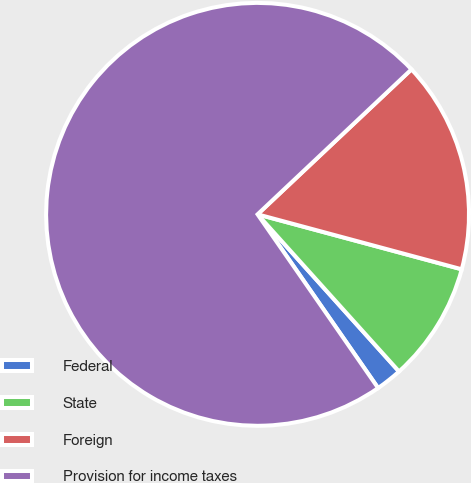Convert chart to OTSL. <chart><loc_0><loc_0><loc_500><loc_500><pie_chart><fcel>Federal<fcel>State<fcel>Foreign<fcel>Provision for income taxes<nl><fcel>2.01%<fcel>9.15%<fcel>16.21%<fcel>72.63%<nl></chart> 